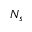Convert formula to latex. <formula><loc_0><loc_0><loc_500><loc_500>N _ { s }</formula> 